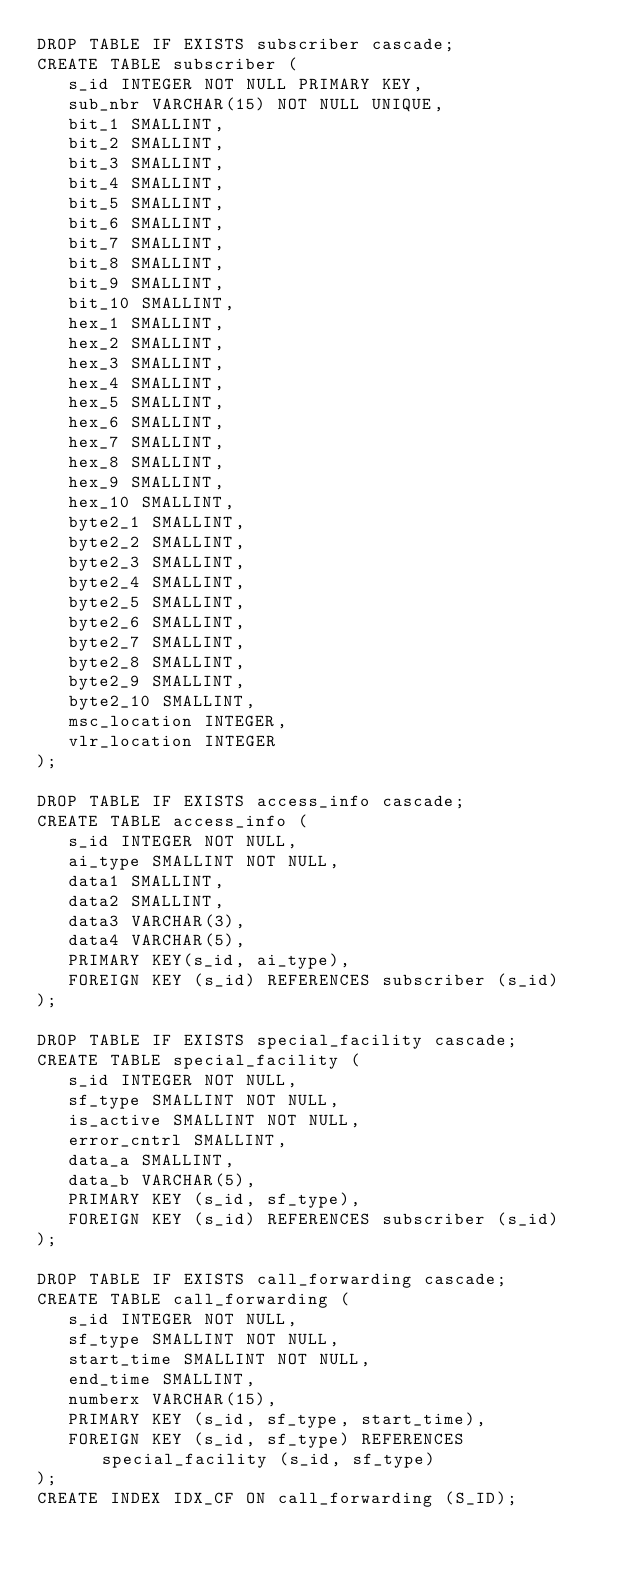Convert code to text. <code><loc_0><loc_0><loc_500><loc_500><_SQL_>DROP TABLE IF EXISTS subscriber cascade;
CREATE TABLE subscriber (
   s_id INTEGER NOT NULL PRIMARY KEY,
   sub_nbr VARCHAR(15) NOT NULL UNIQUE,
   bit_1 SMALLINT,
   bit_2 SMALLINT,
   bit_3 SMALLINT,
   bit_4 SMALLINT,
   bit_5 SMALLINT,
   bit_6 SMALLINT,
   bit_7 SMALLINT,
   bit_8 SMALLINT,
   bit_9 SMALLINT,
   bit_10 SMALLINT,
   hex_1 SMALLINT,
   hex_2 SMALLINT,
   hex_3 SMALLINT,
   hex_4 SMALLINT,
   hex_5 SMALLINT,
   hex_6 SMALLINT,
   hex_7 SMALLINT,
   hex_8 SMALLINT,
   hex_9 SMALLINT,
   hex_10 SMALLINT,
   byte2_1 SMALLINT,
   byte2_2 SMALLINT,
   byte2_3 SMALLINT,
   byte2_4 SMALLINT,
   byte2_5 SMALLINT,
   byte2_6 SMALLINT,
   byte2_7 SMALLINT,
   byte2_8 SMALLINT,
   byte2_9 SMALLINT,
   byte2_10 SMALLINT,
   msc_location INTEGER,
   vlr_location INTEGER
);

DROP TABLE IF EXISTS access_info cascade;
CREATE TABLE access_info (
   s_id INTEGER NOT NULL,
   ai_type SMALLINT NOT NULL,
   data1 SMALLINT,
   data2 SMALLINT,
   data3 VARCHAR(3),
   data4 VARCHAR(5),
   PRIMARY KEY(s_id, ai_type),
   FOREIGN KEY (s_id) REFERENCES subscriber (s_id)
);

DROP TABLE IF EXISTS special_facility cascade;
CREATE TABLE special_facility (
   s_id INTEGER NOT NULL,
   sf_type SMALLINT NOT NULL,
   is_active SMALLINT NOT NULL,
   error_cntrl SMALLINT,
   data_a SMALLINT,
   data_b VARCHAR(5),
   PRIMARY KEY (s_id, sf_type),
   FOREIGN KEY (s_id) REFERENCES subscriber (s_id)
);

DROP TABLE IF EXISTS call_forwarding cascade;
CREATE TABLE call_forwarding (
   s_id INTEGER NOT NULL,
   sf_type SMALLINT NOT NULL,
   start_time SMALLINT NOT NULL,
   end_time SMALLINT,
   numberx VARCHAR(15),
   PRIMARY KEY (s_id, sf_type, start_time),
   FOREIGN KEY (s_id, sf_type) REFERENCES special_facility (s_id, sf_type)
);
CREATE INDEX IDX_CF ON call_forwarding (S_ID);</code> 